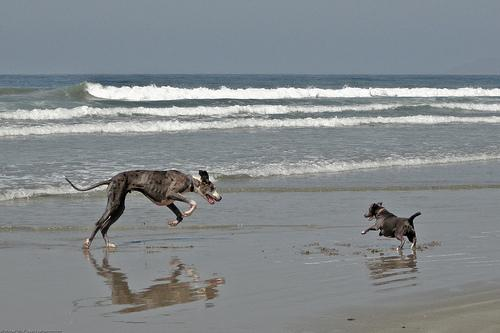Count the total number of paws visible in the image. Eight paws are visible in the image, with four paws each for the large and small dogs. Give a brief description of the background of the image. The ocean is in the background with small waves and a blue sky above it. What distinguishes the two dogs in the image from each other? The bigger dog is a greyhound and the smaller dog is a terrier, with the greyhound's ribs protruding and the terrier having a stubbie tail. Provide a brief analysis of the interaction between the two dogs in the image. The two dogs seem to be actively engaged in running or playing on the beach, as their front feet are off the ground and they appear to be in motion. Do the dogs in the image have their feet on the ground or in the air? Both the bigger and smaller dogs have their front feet off of the ground. What emotion might the image evoke in a viewer? The image may evoke a sense of joy, as it depicts two dogs playfully running on a beautiful beach with sun and waves in the background. Mention one visible interaction between the subjects and the environment in the image. There are paw prints on the beach from the dogs running on the wet sand. What are the two main subjects in the image and where are they located? Two dogs, one bigger and one smaller, are on a beach with the bigger dog on the left and the smaller dog on the right. Evaluate the quality of the image based on the clarity and object placement. The image quality is high, as there are clear distinctions between the objects, such as the two dogs, the ocean, and the sky, and the placement of objects is well-organized and visually appealing. Describe an object in the image that provides context or sets the mood. The ocean, with its blue hue and small waves breaking against the shore, gives a peaceful atmosphere to the scene. 